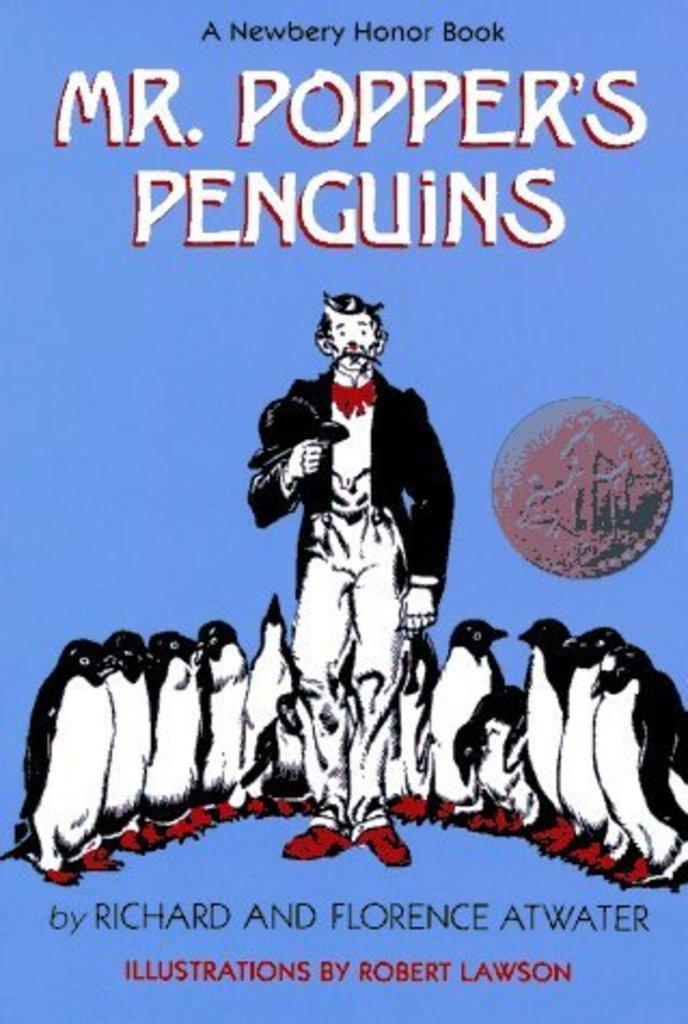<image>
Summarize the visual content of the image. A book cover for Mr. Popper's Penguins showing a man and penguins 